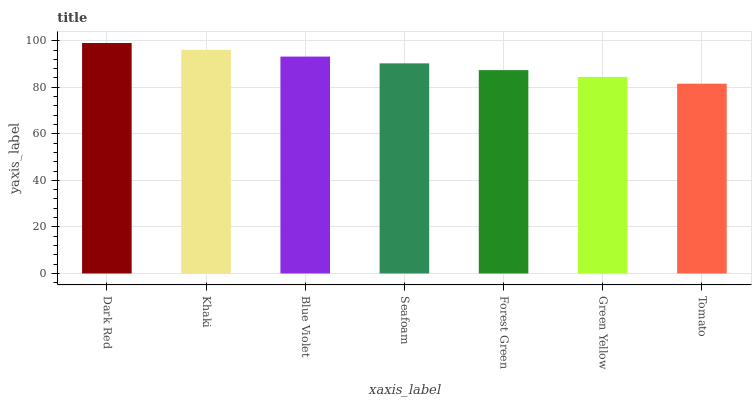Is Tomato the minimum?
Answer yes or no. Yes. Is Dark Red the maximum?
Answer yes or no. Yes. Is Khaki the minimum?
Answer yes or no. No. Is Khaki the maximum?
Answer yes or no. No. Is Dark Red greater than Khaki?
Answer yes or no. Yes. Is Khaki less than Dark Red?
Answer yes or no. Yes. Is Khaki greater than Dark Red?
Answer yes or no. No. Is Dark Red less than Khaki?
Answer yes or no. No. Is Seafoam the high median?
Answer yes or no. Yes. Is Seafoam the low median?
Answer yes or no. Yes. Is Green Yellow the high median?
Answer yes or no. No. Is Khaki the low median?
Answer yes or no. No. 